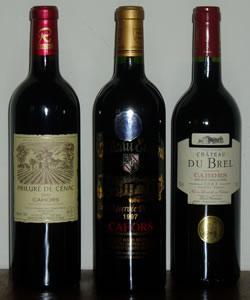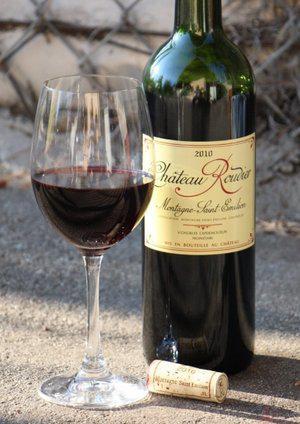The first image is the image on the left, the second image is the image on the right. Assess this claim about the two images: "A green wine bottle is to the right of a glass of wine in the right image.". Correct or not? Answer yes or no. Yes. 